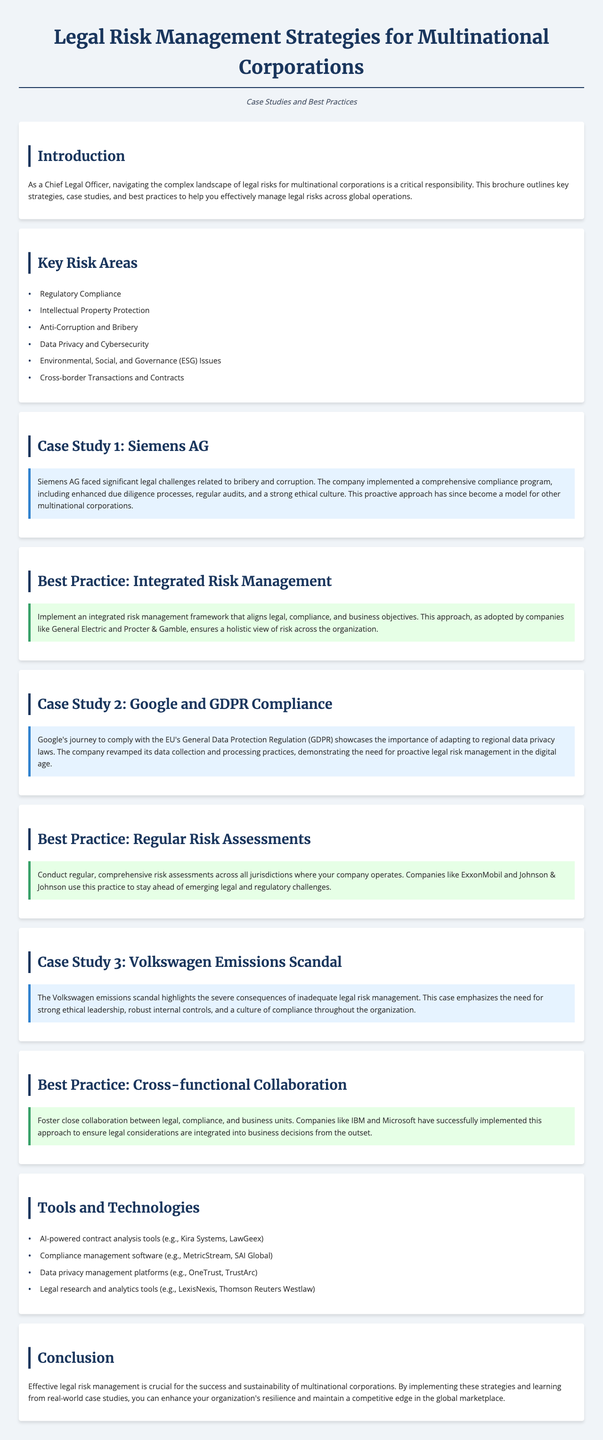What are the key risk areas for multinational corporations? The key risk areas are listed in the document, specifically focused on legal risks faced by multinational corporations.
Answer: Regulatory Compliance, Intellectual Property Protection, Anti-Corruption and Bribery, Data Privacy and Cybersecurity, Environmental, Social, and Governance (ESG) Issues, Cross-border Transactions and Contracts What compliance program did Siemens AG implement? The document mentions that Siemens AG implemented a comprehensive compliance program including various measures.
Answer: Enhanced due diligence processes, regular audits, and a strong ethical culture What is one best practice for legal risk management mentioned? The document provides various best practices, one of which focuses on integrating risk management.
Answer: Integrated risk management framework How did Google adapt to data privacy laws? The document notes the actions taken by Google to comply with regional laws, particularly GDPR.
Answer: Revamped data collection and processing practices Which case study emphasizes the importance of ethical leadership? The case study discusses the consequences of poor legal risk management and highlights the need for ethical leadership.
Answer: Volkswagen Emissions Scandal What type of tools and technologies are mentioned for legal risk management? The document outlines specific tools used in legal risk management for multinational firms.
Answer: AI-powered contract analysis tools, Compliance management software, Data privacy management platforms, Legal research and analytics tools 